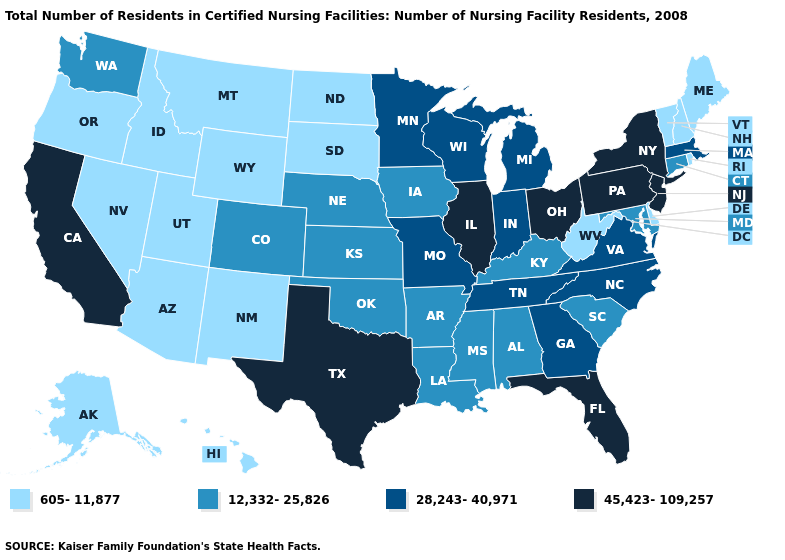Does the first symbol in the legend represent the smallest category?
Give a very brief answer. Yes. What is the value of Hawaii?
Be succinct. 605-11,877. Does the first symbol in the legend represent the smallest category?
Keep it brief. Yes. What is the highest value in states that border Louisiana?
Write a very short answer. 45,423-109,257. Does Alabama have the highest value in the South?
Answer briefly. No. Name the states that have a value in the range 45,423-109,257?
Keep it brief. California, Florida, Illinois, New Jersey, New York, Ohio, Pennsylvania, Texas. Does the map have missing data?
Write a very short answer. No. What is the value of Massachusetts?
Be succinct. 28,243-40,971. Does Arkansas have the highest value in the South?
Keep it brief. No. What is the value of Alabama?
Quick response, please. 12,332-25,826. Which states have the lowest value in the USA?
Be succinct. Alaska, Arizona, Delaware, Hawaii, Idaho, Maine, Montana, Nevada, New Hampshire, New Mexico, North Dakota, Oregon, Rhode Island, South Dakota, Utah, Vermont, West Virginia, Wyoming. Does Florida have the highest value in the South?
Write a very short answer. Yes. What is the lowest value in states that border Massachusetts?
Short answer required. 605-11,877. What is the value of Colorado?
Answer briefly. 12,332-25,826. 